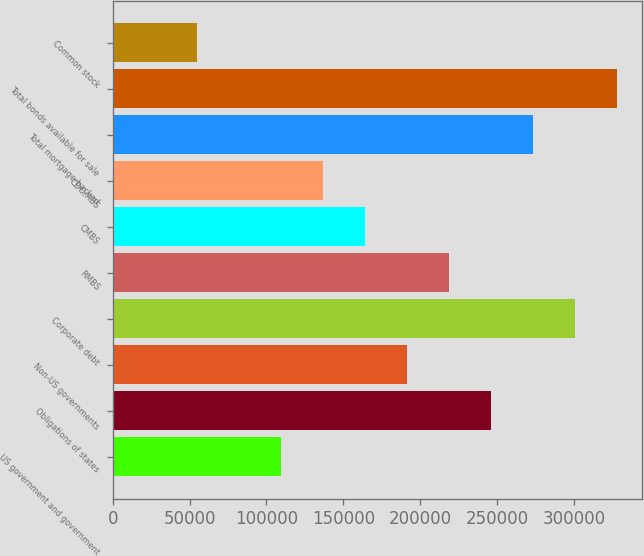Convert chart. <chart><loc_0><loc_0><loc_500><loc_500><bar_chart><fcel>US government and government<fcel>Obligations of states<fcel>Non-US governments<fcel>Corporate debt<fcel>RMBS<fcel>CMBS<fcel>CDO/ABS<fcel>Total mortgage-backed<fcel>Total bonds available for sale<fcel>Common stock<nl><fcel>109315<fcel>245862<fcel>191243<fcel>300480<fcel>218552<fcel>163934<fcel>136624<fcel>273171<fcel>327790<fcel>54696.6<nl></chart> 